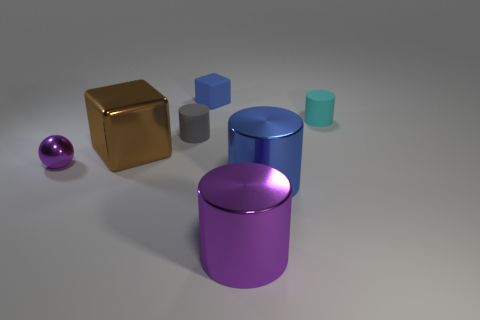Subtract all purple cylinders. How many cylinders are left? 3 Add 1 large shiny objects. How many objects exist? 8 Subtract all blue blocks. How many blocks are left? 1 Subtract all cylinders. How many objects are left? 3 Subtract 4 cylinders. How many cylinders are left? 0 Add 2 small purple balls. How many small purple balls are left? 3 Add 1 tiny yellow blocks. How many tiny yellow blocks exist? 1 Subtract 0 purple blocks. How many objects are left? 7 Subtract all brown spheres. Subtract all purple blocks. How many spheres are left? 1 Subtract all tiny cyan cylinders. Subtract all blue metallic objects. How many objects are left? 5 